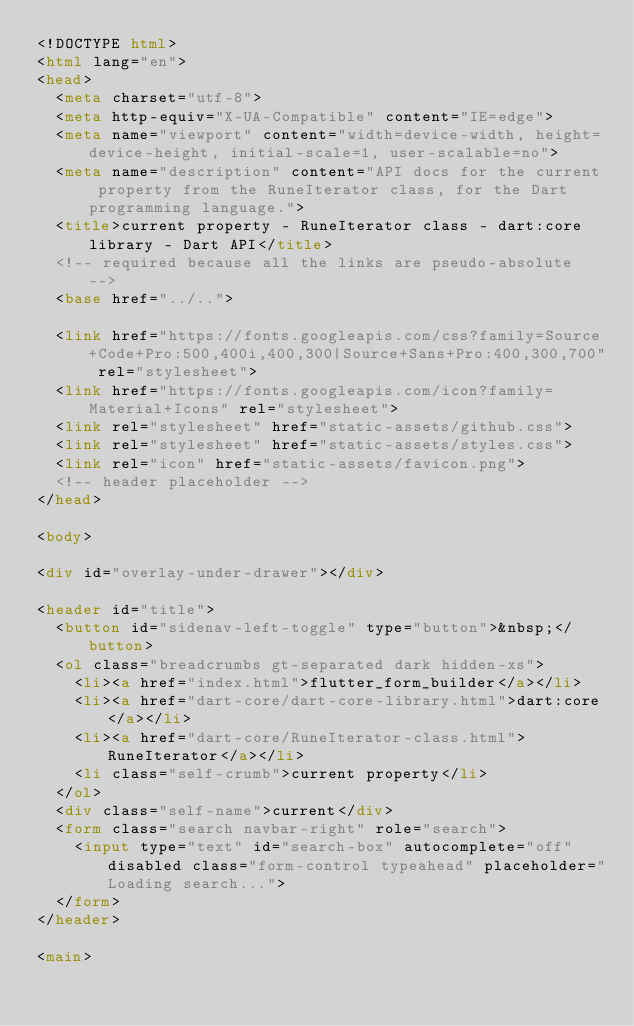Convert code to text. <code><loc_0><loc_0><loc_500><loc_500><_HTML_><!DOCTYPE html>
<html lang="en">
<head>
  <meta charset="utf-8">
  <meta http-equiv="X-UA-Compatible" content="IE=edge">
  <meta name="viewport" content="width=device-width, height=device-height, initial-scale=1, user-scalable=no">
  <meta name="description" content="API docs for the current property from the RuneIterator class, for the Dart programming language.">
  <title>current property - RuneIterator class - dart:core library - Dart API</title>
  <!-- required because all the links are pseudo-absolute -->
  <base href="../..">

  <link href="https://fonts.googleapis.com/css?family=Source+Code+Pro:500,400i,400,300|Source+Sans+Pro:400,300,700" rel="stylesheet">
  <link href="https://fonts.googleapis.com/icon?family=Material+Icons" rel="stylesheet">
  <link rel="stylesheet" href="static-assets/github.css">
  <link rel="stylesheet" href="static-assets/styles.css">
  <link rel="icon" href="static-assets/favicon.png">
  <!-- header placeholder -->
</head>

<body>

<div id="overlay-under-drawer"></div>

<header id="title">
  <button id="sidenav-left-toggle" type="button">&nbsp;</button>
  <ol class="breadcrumbs gt-separated dark hidden-xs">
    <li><a href="index.html">flutter_form_builder</a></li>
    <li><a href="dart-core/dart-core-library.html">dart:core</a></li>
    <li><a href="dart-core/RuneIterator-class.html">RuneIterator</a></li>
    <li class="self-crumb">current property</li>
  </ol>
  <div class="self-name">current</div>
  <form class="search navbar-right" role="search">
    <input type="text" id="search-box" autocomplete="off" disabled class="form-control typeahead" placeholder="Loading search...">
  </form>
</header>

<main>
</code> 